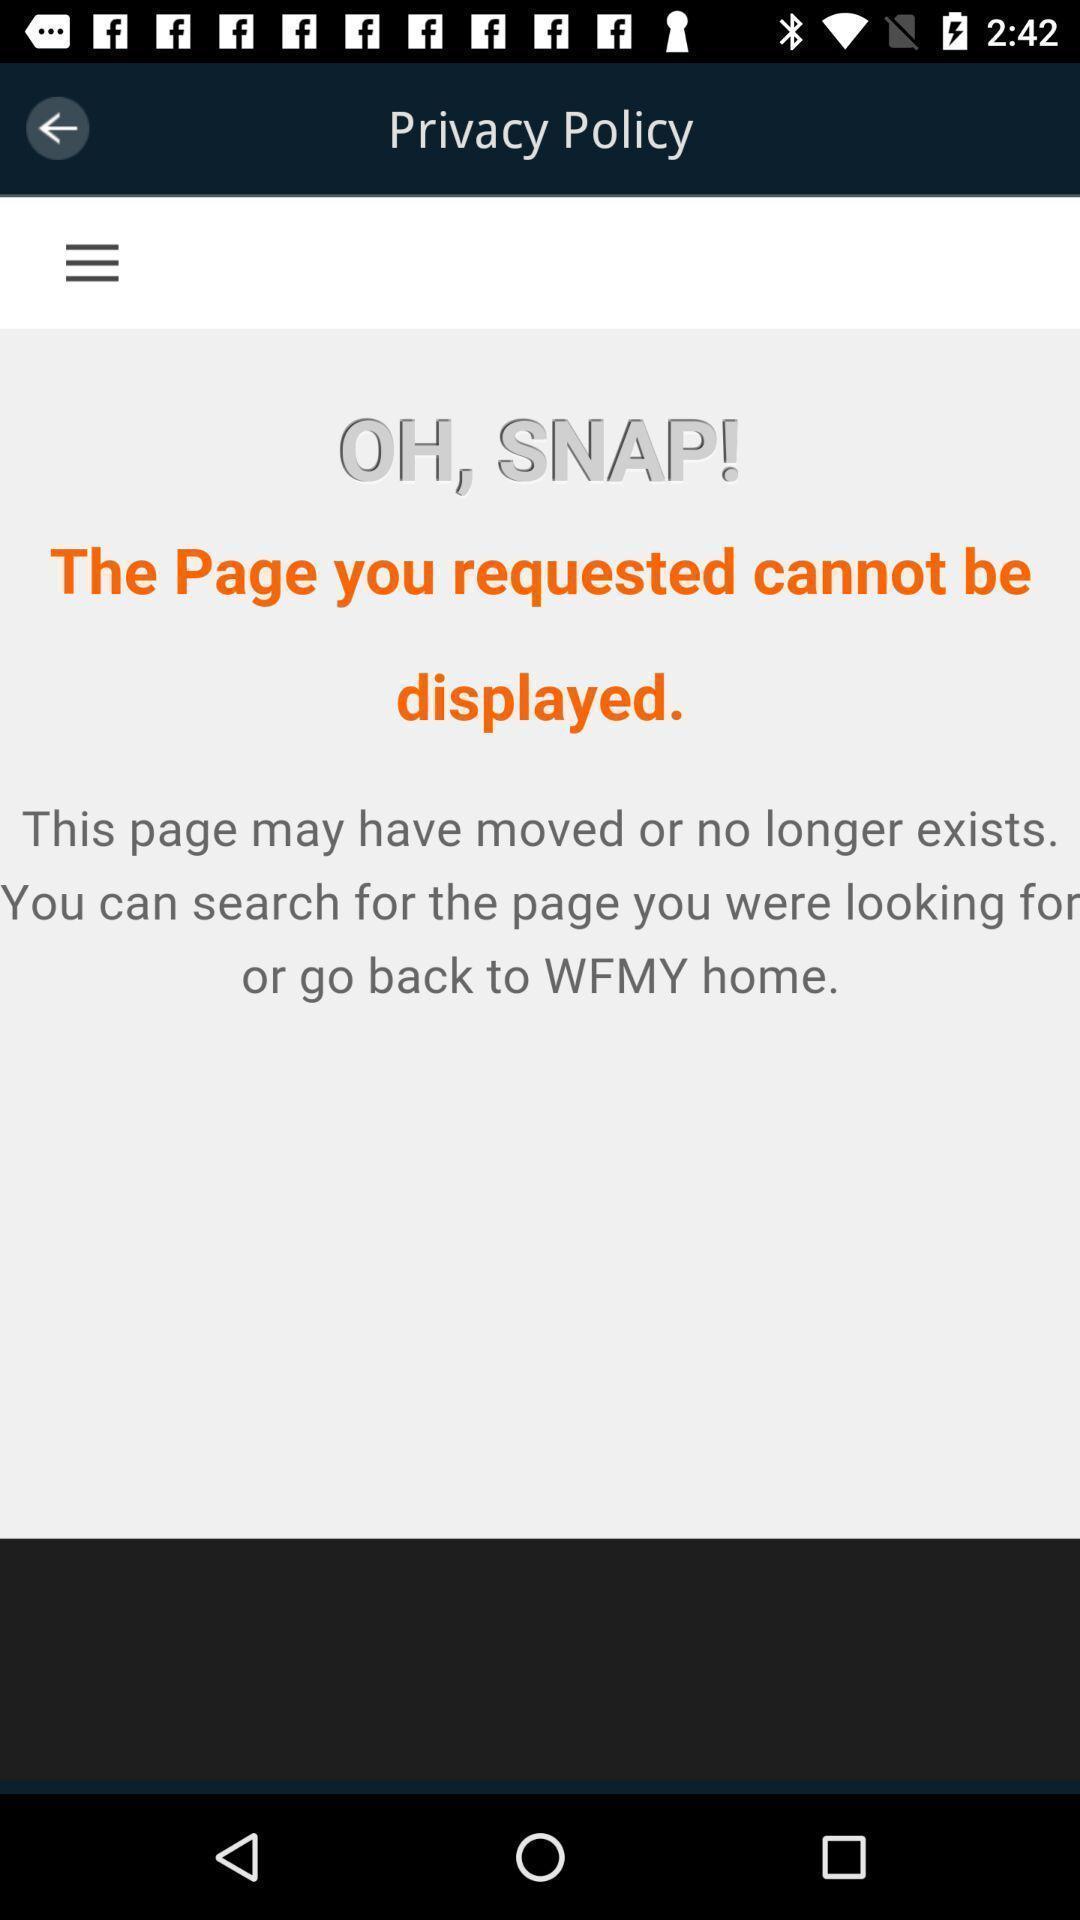Tell me what you see in this picture. Privacy policy page showing a message. 